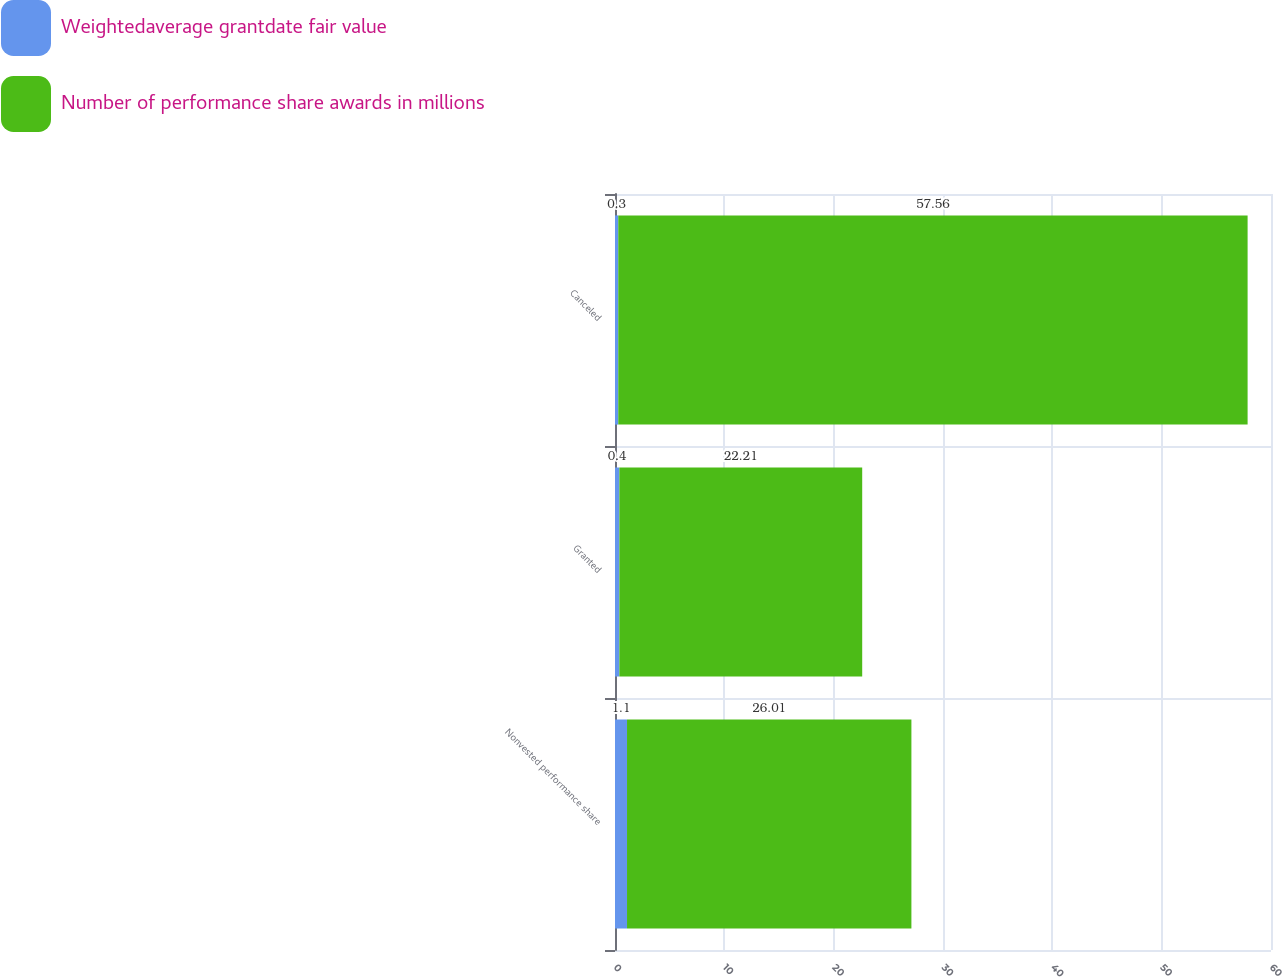Convert chart to OTSL. <chart><loc_0><loc_0><loc_500><loc_500><stacked_bar_chart><ecel><fcel>Nonvested performance share<fcel>Granted<fcel>Canceled<nl><fcel>Weightedaverage grantdate fair value<fcel>1.1<fcel>0.4<fcel>0.3<nl><fcel>Number of performance share awards in millions<fcel>26.01<fcel>22.21<fcel>57.56<nl></chart> 